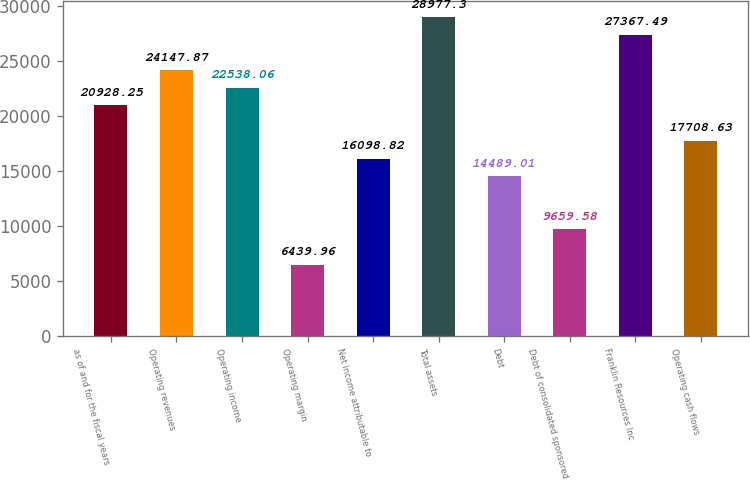Convert chart. <chart><loc_0><loc_0><loc_500><loc_500><bar_chart><fcel>as of and for the fiscal years<fcel>Operating revenues<fcel>Operating income<fcel>Operating margin<fcel>Net income attributable to<fcel>Total assets<fcel>Debt<fcel>Debt of consolidated sponsored<fcel>Franklin Resources Inc<fcel>Operating cash flows<nl><fcel>20928.2<fcel>24147.9<fcel>22538.1<fcel>6439.96<fcel>16098.8<fcel>28977.3<fcel>14489<fcel>9659.58<fcel>27367.5<fcel>17708.6<nl></chart> 